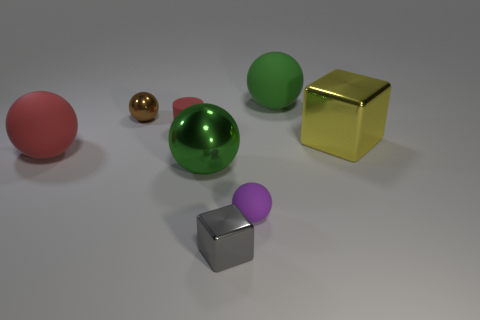Subtract all tiny purple balls. How many balls are left? 4 Add 1 small rubber cylinders. How many objects exist? 9 Subtract all green balls. How many balls are left? 3 Subtract all cylinders. How many objects are left? 7 Subtract 2 blocks. How many blocks are left? 0 Subtract all yellow cylinders. Subtract all brown blocks. How many cylinders are left? 1 Subtract all gray spheres. How many cyan blocks are left? 0 Subtract all tiny green shiny cylinders. Subtract all large rubber spheres. How many objects are left? 6 Add 2 yellow metal objects. How many yellow metal objects are left? 3 Add 4 green cubes. How many green cubes exist? 4 